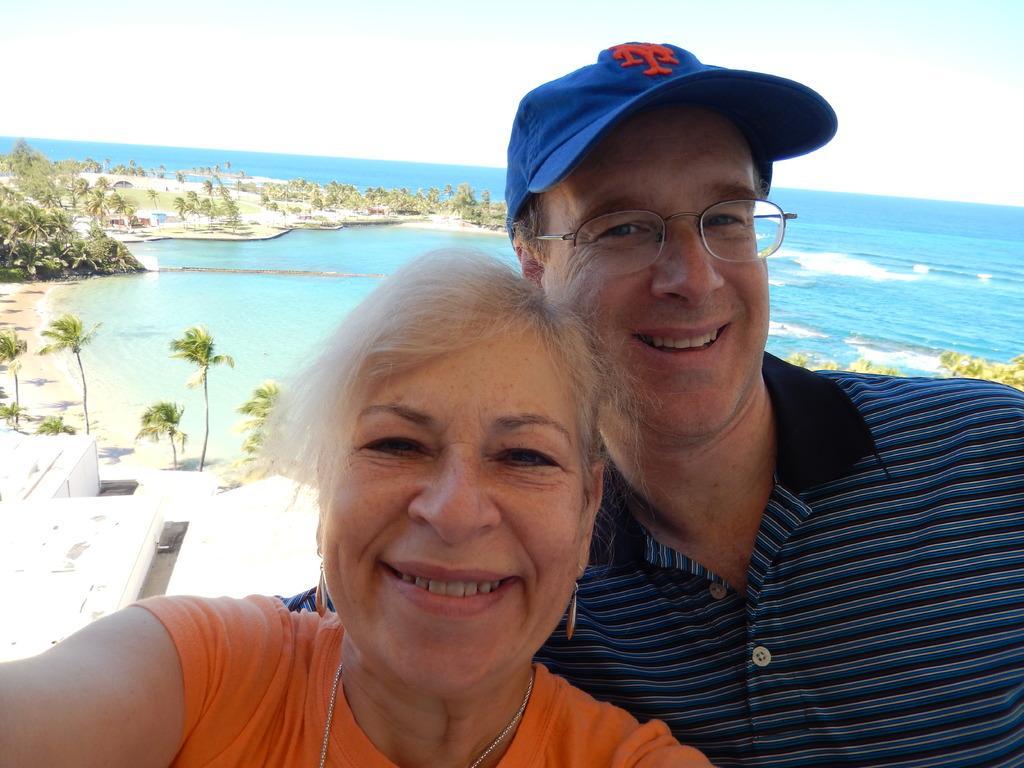Describe this image in one or two sentences. In the front of the image I can see a man and woman are smiling. Man wore spectacles and cap. In the background of the image there is water, trees, building and sky. 